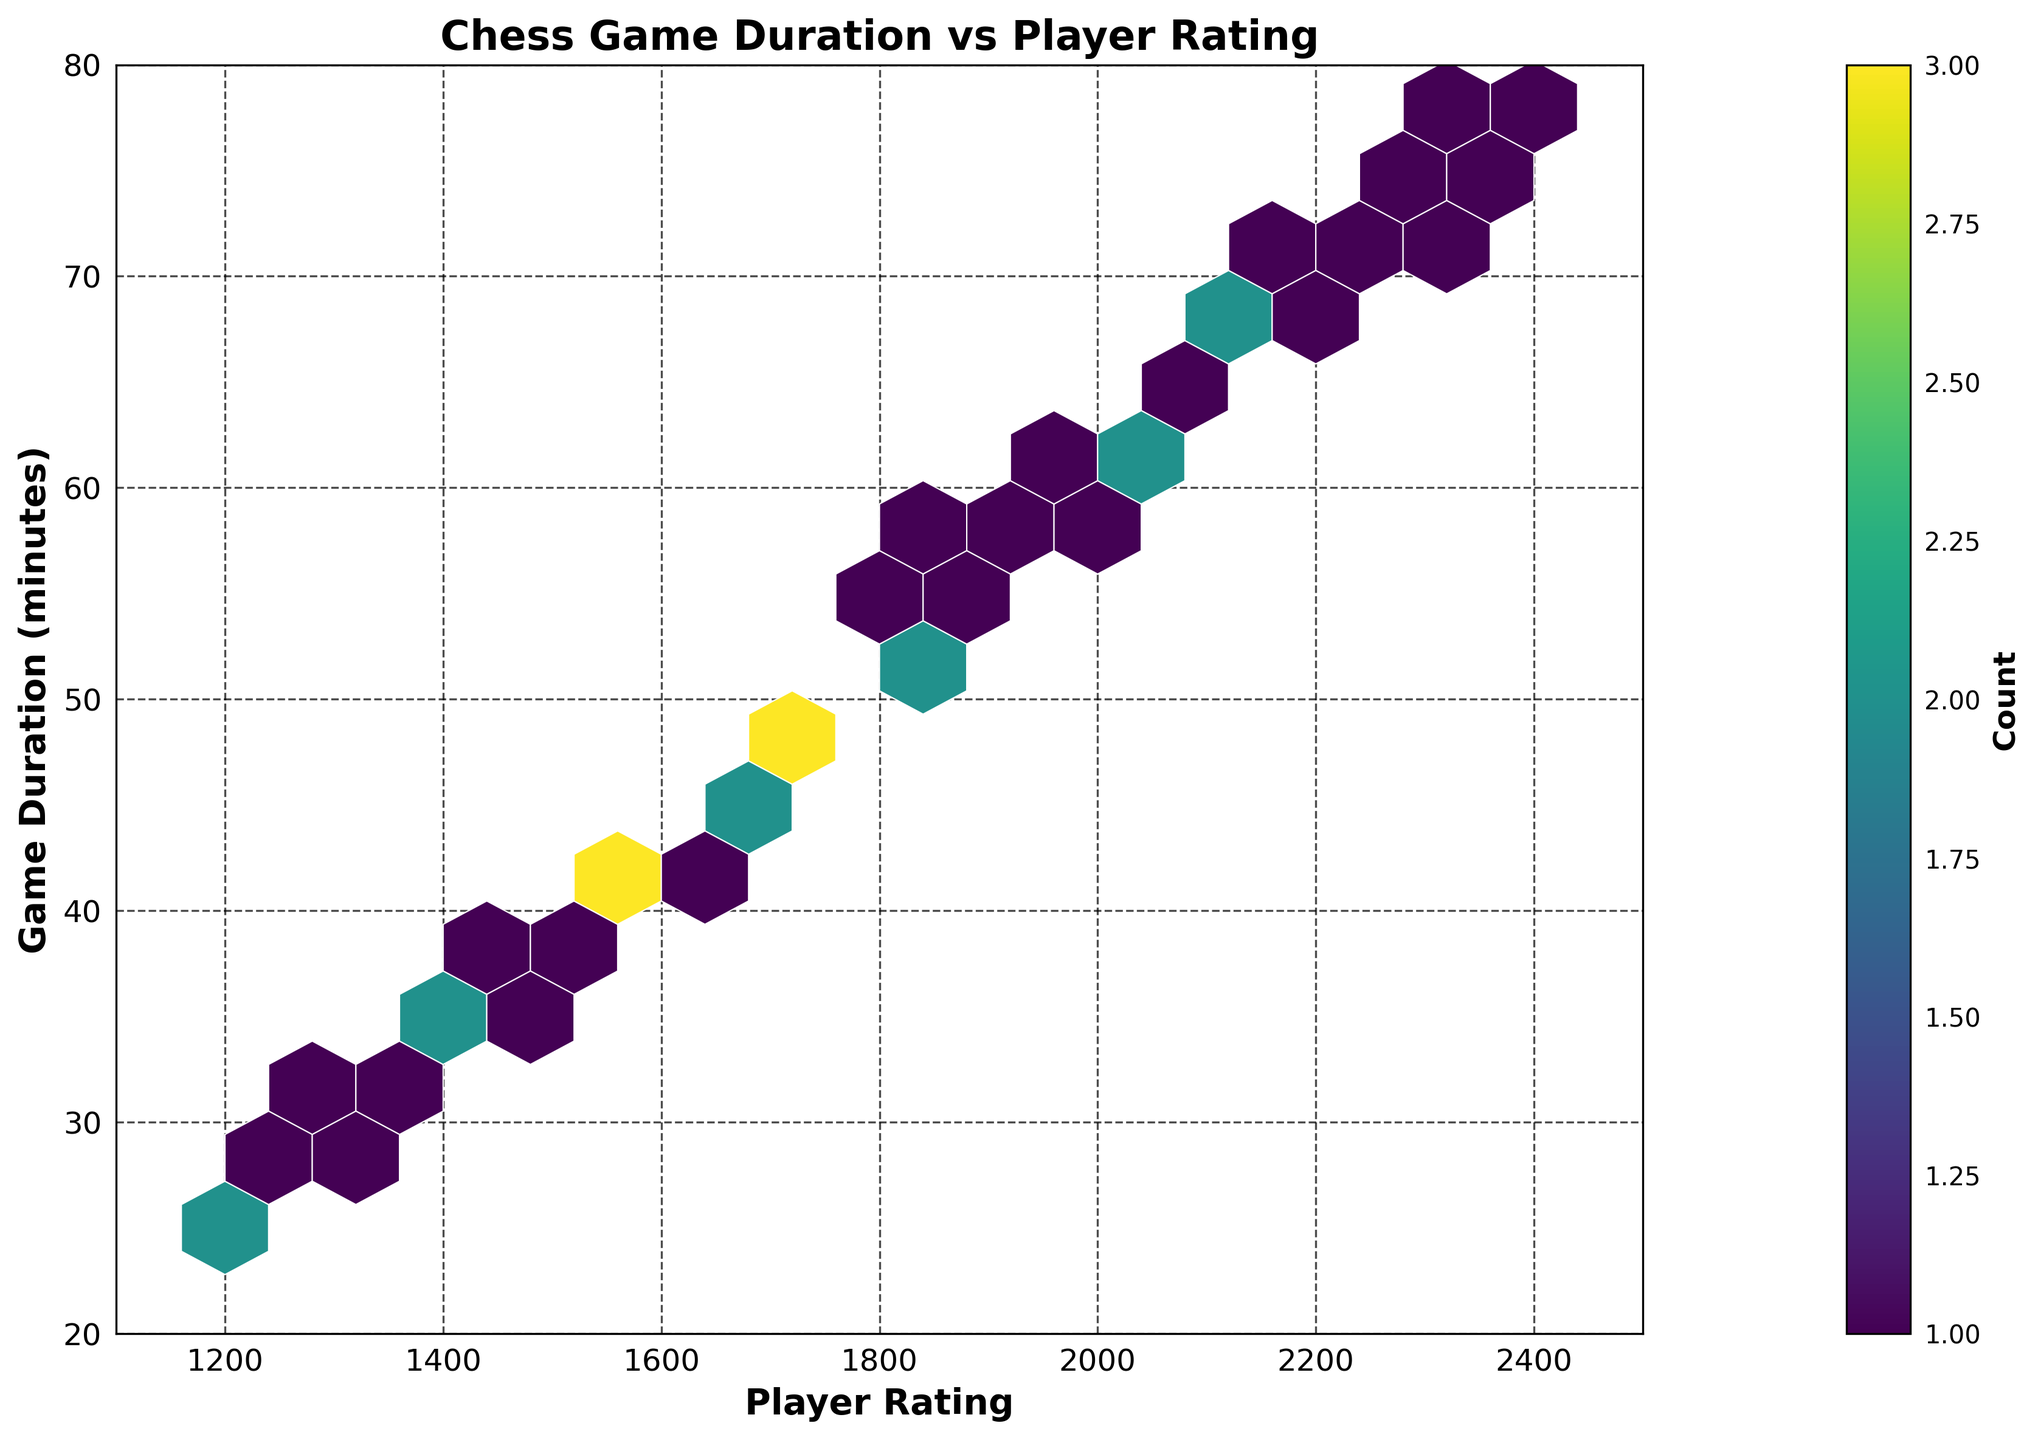What is the title of the plot? The title of the plot is displayed at the top. It reads "Chess Game Duration vs Player Rating".
Answer: Chess Game Duration vs Player Rating What are the labels for the x-axis and y-axis? The x-axis label, found at the bottom of the plot, is "Player Rating". The y-axis label, found on the left side, is "Game Duration (minutes)".
Answer: Player Rating and Game Duration (minutes) Within what range does the Player Rating vary? Observing the x-axis of the plot, Player Rating ranges from 1100 to 2500.
Answer: 1100 to 2500 What color map is used to represent the hexagons in the plot? The hexagons are colored using the 'viridis' color map, which transitions from dark purple to yellow. This can be inferred from the color transition seen in the plot.
Answer: viridis Which range of Player Rating tends to have the shortest game duration? By observing the densest (most frequent) hexagons near the lower part of the plot, Player Ratings around 1200 to 1400 tend to have shorter game durations, generally between 25 to 35 minutes.
Answer: 1200 to 1400 What is the count indicated by the color bar that corresponds to the highest frequency hexbin region? The color bar shows the counts with intervals; the highest frequency region is represented by the lightest color, which indicates a count of more than 6.
Answer: More than 6 How do game durations change as player ratings increase from 1200 to 2400? As we move from the left (1200) to the right (2400) on the x-axis, the hexagons indicate that game durations generally increase from around 25 minutes to around 75 minutes.
Answer: Game durations increase Are there any specific Player Rating ranges where game durations are less variable? By examining the spread of hexagons vertically at different Player Rating ranges, around the 1900 to 2100 range, the game durations seem to cluster more tightly, indicating less variability.
Answer: 1900 to 2100 Is there any visible correlation between Player Rating and Game Duration? The hexbin plot shows a general upward trend where hexagons spread diagonally from bottom left to top right. This indicates a positive correlation: higher Player Ratings tend to have longer game durations.
Answer: Positive correlation Which range of game durations is most frequently observed for Player Ratings between 1600 and 1800? Examining the hexbin density within the 1600 to 1800 Player Rating range, the majority of the game durations fall between 40 to 50 minutes.
Answer: 40 to 50 minutes 